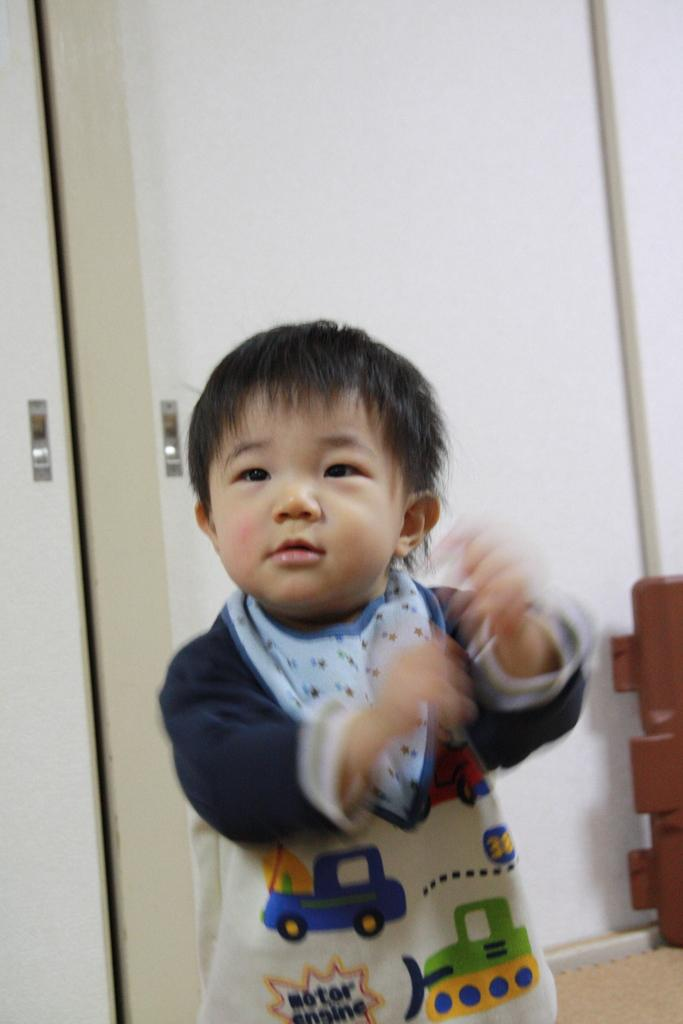What is the main subject in the foreground of the image? There is a boy standing in the foreground of the image. What can be seen in the background of the image? There are doors and a wall in the background of the image. Can you describe the object in the background of the image? Unfortunately, the provided facts do not give enough information to describe the object in the background. How many quince are on the stage in the image? There is no stage or quince present in the image. What are the men in the image doing? There are no men present in the image; it features a boy in the foreground and an unspecified object in the background. 